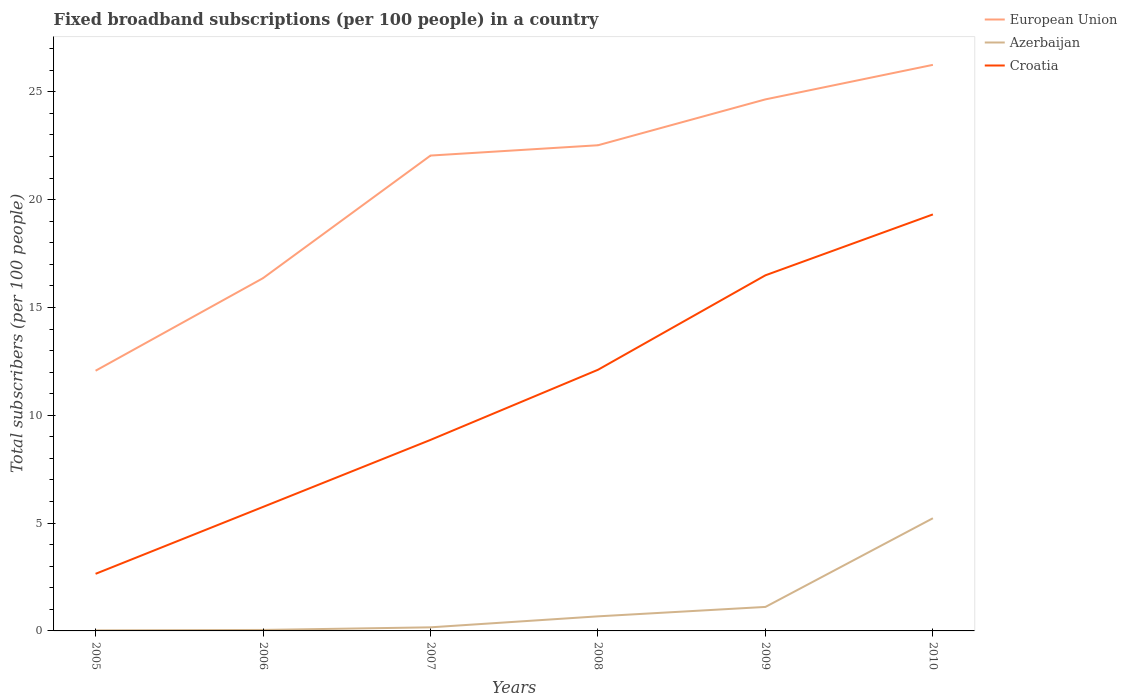How many different coloured lines are there?
Provide a short and direct response. 3. Does the line corresponding to European Union intersect with the line corresponding to Azerbaijan?
Give a very brief answer. No. Is the number of lines equal to the number of legend labels?
Make the answer very short. Yes. Across all years, what is the maximum number of broadband subscriptions in Croatia?
Provide a short and direct response. 2.65. What is the total number of broadband subscriptions in Croatia in the graph?
Offer a terse response. -3.11. What is the difference between the highest and the second highest number of broadband subscriptions in Croatia?
Offer a terse response. 16.67. What is the difference between the highest and the lowest number of broadband subscriptions in European Union?
Provide a succinct answer. 4. How many lines are there?
Your answer should be compact. 3. What is the difference between two consecutive major ticks on the Y-axis?
Make the answer very short. 5. How are the legend labels stacked?
Make the answer very short. Vertical. What is the title of the graph?
Provide a short and direct response. Fixed broadband subscriptions (per 100 people) in a country. Does "Egypt, Arab Rep." appear as one of the legend labels in the graph?
Offer a terse response. No. What is the label or title of the Y-axis?
Offer a terse response. Total subscribers (per 100 people). What is the Total subscribers (per 100 people) in European Union in 2005?
Your response must be concise. 12.07. What is the Total subscribers (per 100 people) of Azerbaijan in 2005?
Give a very brief answer. 0.03. What is the Total subscribers (per 100 people) of Croatia in 2005?
Your response must be concise. 2.65. What is the Total subscribers (per 100 people) of European Union in 2006?
Give a very brief answer. 16.36. What is the Total subscribers (per 100 people) in Azerbaijan in 2006?
Keep it short and to the point. 0.05. What is the Total subscribers (per 100 people) in Croatia in 2006?
Give a very brief answer. 5.75. What is the Total subscribers (per 100 people) in European Union in 2007?
Make the answer very short. 22.04. What is the Total subscribers (per 100 people) in Azerbaijan in 2007?
Ensure brevity in your answer.  0.17. What is the Total subscribers (per 100 people) in Croatia in 2007?
Offer a terse response. 8.86. What is the Total subscribers (per 100 people) in European Union in 2008?
Provide a short and direct response. 22.52. What is the Total subscribers (per 100 people) of Azerbaijan in 2008?
Your answer should be compact. 0.68. What is the Total subscribers (per 100 people) in Croatia in 2008?
Give a very brief answer. 12.11. What is the Total subscribers (per 100 people) of European Union in 2009?
Keep it short and to the point. 24.65. What is the Total subscribers (per 100 people) in Azerbaijan in 2009?
Give a very brief answer. 1.11. What is the Total subscribers (per 100 people) in Croatia in 2009?
Give a very brief answer. 16.49. What is the Total subscribers (per 100 people) in European Union in 2010?
Offer a very short reply. 26.25. What is the Total subscribers (per 100 people) in Azerbaijan in 2010?
Make the answer very short. 5.23. What is the Total subscribers (per 100 people) of Croatia in 2010?
Your answer should be very brief. 19.31. Across all years, what is the maximum Total subscribers (per 100 people) of European Union?
Offer a terse response. 26.25. Across all years, what is the maximum Total subscribers (per 100 people) in Azerbaijan?
Offer a terse response. 5.23. Across all years, what is the maximum Total subscribers (per 100 people) of Croatia?
Give a very brief answer. 19.31. Across all years, what is the minimum Total subscribers (per 100 people) of European Union?
Keep it short and to the point. 12.07. Across all years, what is the minimum Total subscribers (per 100 people) in Azerbaijan?
Give a very brief answer. 0.03. Across all years, what is the minimum Total subscribers (per 100 people) in Croatia?
Give a very brief answer. 2.65. What is the total Total subscribers (per 100 people) in European Union in the graph?
Provide a succinct answer. 123.89. What is the total Total subscribers (per 100 people) of Azerbaijan in the graph?
Ensure brevity in your answer.  7.25. What is the total Total subscribers (per 100 people) of Croatia in the graph?
Offer a very short reply. 65.17. What is the difference between the Total subscribers (per 100 people) in European Union in 2005 and that in 2006?
Your response must be concise. -4.29. What is the difference between the Total subscribers (per 100 people) in Azerbaijan in 2005 and that in 2006?
Offer a very short reply. -0.02. What is the difference between the Total subscribers (per 100 people) in Croatia in 2005 and that in 2006?
Make the answer very short. -3.1. What is the difference between the Total subscribers (per 100 people) of European Union in 2005 and that in 2007?
Make the answer very short. -9.98. What is the difference between the Total subscribers (per 100 people) in Azerbaijan in 2005 and that in 2007?
Keep it short and to the point. -0.14. What is the difference between the Total subscribers (per 100 people) of Croatia in 2005 and that in 2007?
Make the answer very short. -6.21. What is the difference between the Total subscribers (per 100 people) in European Union in 2005 and that in 2008?
Ensure brevity in your answer.  -10.46. What is the difference between the Total subscribers (per 100 people) in Azerbaijan in 2005 and that in 2008?
Offer a very short reply. -0.65. What is the difference between the Total subscribers (per 100 people) of Croatia in 2005 and that in 2008?
Provide a short and direct response. -9.46. What is the difference between the Total subscribers (per 100 people) in European Union in 2005 and that in 2009?
Provide a succinct answer. -12.58. What is the difference between the Total subscribers (per 100 people) of Azerbaijan in 2005 and that in 2009?
Ensure brevity in your answer.  -1.09. What is the difference between the Total subscribers (per 100 people) of Croatia in 2005 and that in 2009?
Your answer should be compact. -13.84. What is the difference between the Total subscribers (per 100 people) in European Union in 2005 and that in 2010?
Make the answer very short. -14.18. What is the difference between the Total subscribers (per 100 people) in Azerbaijan in 2005 and that in 2010?
Provide a short and direct response. -5.2. What is the difference between the Total subscribers (per 100 people) of Croatia in 2005 and that in 2010?
Your answer should be compact. -16.67. What is the difference between the Total subscribers (per 100 people) in European Union in 2006 and that in 2007?
Ensure brevity in your answer.  -5.68. What is the difference between the Total subscribers (per 100 people) in Azerbaijan in 2006 and that in 2007?
Keep it short and to the point. -0.12. What is the difference between the Total subscribers (per 100 people) of Croatia in 2006 and that in 2007?
Ensure brevity in your answer.  -3.11. What is the difference between the Total subscribers (per 100 people) of European Union in 2006 and that in 2008?
Make the answer very short. -6.16. What is the difference between the Total subscribers (per 100 people) in Azerbaijan in 2006 and that in 2008?
Keep it short and to the point. -0.63. What is the difference between the Total subscribers (per 100 people) in Croatia in 2006 and that in 2008?
Give a very brief answer. -6.36. What is the difference between the Total subscribers (per 100 people) of European Union in 2006 and that in 2009?
Make the answer very short. -8.29. What is the difference between the Total subscribers (per 100 people) of Azerbaijan in 2006 and that in 2009?
Provide a succinct answer. -1.07. What is the difference between the Total subscribers (per 100 people) in Croatia in 2006 and that in 2009?
Your answer should be compact. -10.74. What is the difference between the Total subscribers (per 100 people) in European Union in 2006 and that in 2010?
Your answer should be very brief. -9.89. What is the difference between the Total subscribers (per 100 people) in Azerbaijan in 2006 and that in 2010?
Offer a terse response. -5.18. What is the difference between the Total subscribers (per 100 people) of Croatia in 2006 and that in 2010?
Give a very brief answer. -13.56. What is the difference between the Total subscribers (per 100 people) of European Union in 2007 and that in 2008?
Keep it short and to the point. -0.48. What is the difference between the Total subscribers (per 100 people) of Azerbaijan in 2007 and that in 2008?
Provide a succinct answer. -0.51. What is the difference between the Total subscribers (per 100 people) in Croatia in 2007 and that in 2008?
Ensure brevity in your answer.  -3.25. What is the difference between the Total subscribers (per 100 people) of European Union in 2007 and that in 2009?
Keep it short and to the point. -2.61. What is the difference between the Total subscribers (per 100 people) of Azerbaijan in 2007 and that in 2009?
Provide a short and direct response. -0.95. What is the difference between the Total subscribers (per 100 people) of Croatia in 2007 and that in 2009?
Your answer should be compact. -7.63. What is the difference between the Total subscribers (per 100 people) of European Union in 2007 and that in 2010?
Your response must be concise. -4.21. What is the difference between the Total subscribers (per 100 people) in Azerbaijan in 2007 and that in 2010?
Provide a short and direct response. -5.06. What is the difference between the Total subscribers (per 100 people) in Croatia in 2007 and that in 2010?
Ensure brevity in your answer.  -10.46. What is the difference between the Total subscribers (per 100 people) of European Union in 2008 and that in 2009?
Your answer should be very brief. -2.13. What is the difference between the Total subscribers (per 100 people) in Azerbaijan in 2008 and that in 2009?
Your answer should be very brief. -0.44. What is the difference between the Total subscribers (per 100 people) in Croatia in 2008 and that in 2009?
Offer a very short reply. -4.38. What is the difference between the Total subscribers (per 100 people) of European Union in 2008 and that in 2010?
Give a very brief answer. -3.73. What is the difference between the Total subscribers (per 100 people) in Azerbaijan in 2008 and that in 2010?
Give a very brief answer. -4.55. What is the difference between the Total subscribers (per 100 people) in Croatia in 2008 and that in 2010?
Ensure brevity in your answer.  -7.2. What is the difference between the Total subscribers (per 100 people) in European Union in 2009 and that in 2010?
Ensure brevity in your answer.  -1.6. What is the difference between the Total subscribers (per 100 people) of Azerbaijan in 2009 and that in 2010?
Provide a short and direct response. -4.11. What is the difference between the Total subscribers (per 100 people) of Croatia in 2009 and that in 2010?
Make the answer very short. -2.82. What is the difference between the Total subscribers (per 100 people) of European Union in 2005 and the Total subscribers (per 100 people) of Azerbaijan in 2006?
Offer a terse response. 12.02. What is the difference between the Total subscribers (per 100 people) of European Union in 2005 and the Total subscribers (per 100 people) of Croatia in 2006?
Make the answer very short. 6.31. What is the difference between the Total subscribers (per 100 people) of Azerbaijan in 2005 and the Total subscribers (per 100 people) of Croatia in 2006?
Ensure brevity in your answer.  -5.73. What is the difference between the Total subscribers (per 100 people) in European Union in 2005 and the Total subscribers (per 100 people) in Azerbaijan in 2007?
Your answer should be very brief. 11.9. What is the difference between the Total subscribers (per 100 people) of European Union in 2005 and the Total subscribers (per 100 people) of Croatia in 2007?
Provide a succinct answer. 3.21. What is the difference between the Total subscribers (per 100 people) of Azerbaijan in 2005 and the Total subscribers (per 100 people) of Croatia in 2007?
Your answer should be very brief. -8.83. What is the difference between the Total subscribers (per 100 people) of European Union in 2005 and the Total subscribers (per 100 people) of Azerbaijan in 2008?
Your response must be concise. 11.39. What is the difference between the Total subscribers (per 100 people) of European Union in 2005 and the Total subscribers (per 100 people) of Croatia in 2008?
Your answer should be compact. -0.04. What is the difference between the Total subscribers (per 100 people) of Azerbaijan in 2005 and the Total subscribers (per 100 people) of Croatia in 2008?
Provide a short and direct response. -12.08. What is the difference between the Total subscribers (per 100 people) of European Union in 2005 and the Total subscribers (per 100 people) of Azerbaijan in 2009?
Your answer should be compact. 10.95. What is the difference between the Total subscribers (per 100 people) in European Union in 2005 and the Total subscribers (per 100 people) in Croatia in 2009?
Make the answer very short. -4.43. What is the difference between the Total subscribers (per 100 people) in Azerbaijan in 2005 and the Total subscribers (per 100 people) in Croatia in 2009?
Offer a terse response. -16.47. What is the difference between the Total subscribers (per 100 people) in European Union in 2005 and the Total subscribers (per 100 people) in Azerbaijan in 2010?
Keep it short and to the point. 6.84. What is the difference between the Total subscribers (per 100 people) in European Union in 2005 and the Total subscribers (per 100 people) in Croatia in 2010?
Keep it short and to the point. -7.25. What is the difference between the Total subscribers (per 100 people) in Azerbaijan in 2005 and the Total subscribers (per 100 people) in Croatia in 2010?
Your answer should be compact. -19.29. What is the difference between the Total subscribers (per 100 people) of European Union in 2006 and the Total subscribers (per 100 people) of Azerbaijan in 2007?
Make the answer very short. 16.19. What is the difference between the Total subscribers (per 100 people) of European Union in 2006 and the Total subscribers (per 100 people) of Croatia in 2007?
Provide a succinct answer. 7.5. What is the difference between the Total subscribers (per 100 people) of Azerbaijan in 2006 and the Total subscribers (per 100 people) of Croatia in 2007?
Provide a succinct answer. -8.81. What is the difference between the Total subscribers (per 100 people) in European Union in 2006 and the Total subscribers (per 100 people) in Azerbaijan in 2008?
Provide a short and direct response. 15.68. What is the difference between the Total subscribers (per 100 people) of European Union in 2006 and the Total subscribers (per 100 people) of Croatia in 2008?
Your answer should be compact. 4.25. What is the difference between the Total subscribers (per 100 people) of Azerbaijan in 2006 and the Total subscribers (per 100 people) of Croatia in 2008?
Provide a short and direct response. -12.06. What is the difference between the Total subscribers (per 100 people) of European Union in 2006 and the Total subscribers (per 100 people) of Azerbaijan in 2009?
Provide a succinct answer. 15.25. What is the difference between the Total subscribers (per 100 people) in European Union in 2006 and the Total subscribers (per 100 people) in Croatia in 2009?
Your response must be concise. -0.13. What is the difference between the Total subscribers (per 100 people) of Azerbaijan in 2006 and the Total subscribers (per 100 people) of Croatia in 2009?
Your response must be concise. -16.45. What is the difference between the Total subscribers (per 100 people) in European Union in 2006 and the Total subscribers (per 100 people) in Azerbaijan in 2010?
Keep it short and to the point. 11.13. What is the difference between the Total subscribers (per 100 people) in European Union in 2006 and the Total subscribers (per 100 people) in Croatia in 2010?
Make the answer very short. -2.96. What is the difference between the Total subscribers (per 100 people) in Azerbaijan in 2006 and the Total subscribers (per 100 people) in Croatia in 2010?
Offer a terse response. -19.27. What is the difference between the Total subscribers (per 100 people) in European Union in 2007 and the Total subscribers (per 100 people) in Azerbaijan in 2008?
Provide a succinct answer. 21.37. What is the difference between the Total subscribers (per 100 people) in European Union in 2007 and the Total subscribers (per 100 people) in Croatia in 2008?
Your answer should be very brief. 9.93. What is the difference between the Total subscribers (per 100 people) of Azerbaijan in 2007 and the Total subscribers (per 100 people) of Croatia in 2008?
Your answer should be compact. -11.94. What is the difference between the Total subscribers (per 100 people) of European Union in 2007 and the Total subscribers (per 100 people) of Azerbaijan in 2009?
Offer a terse response. 20.93. What is the difference between the Total subscribers (per 100 people) in European Union in 2007 and the Total subscribers (per 100 people) in Croatia in 2009?
Keep it short and to the point. 5.55. What is the difference between the Total subscribers (per 100 people) in Azerbaijan in 2007 and the Total subscribers (per 100 people) in Croatia in 2009?
Your answer should be compact. -16.32. What is the difference between the Total subscribers (per 100 people) in European Union in 2007 and the Total subscribers (per 100 people) in Azerbaijan in 2010?
Make the answer very short. 16.82. What is the difference between the Total subscribers (per 100 people) in European Union in 2007 and the Total subscribers (per 100 people) in Croatia in 2010?
Your answer should be very brief. 2.73. What is the difference between the Total subscribers (per 100 people) in Azerbaijan in 2007 and the Total subscribers (per 100 people) in Croatia in 2010?
Your answer should be very brief. -19.15. What is the difference between the Total subscribers (per 100 people) of European Union in 2008 and the Total subscribers (per 100 people) of Azerbaijan in 2009?
Keep it short and to the point. 21.41. What is the difference between the Total subscribers (per 100 people) of European Union in 2008 and the Total subscribers (per 100 people) of Croatia in 2009?
Keep it short and to the point. 6.03. What is the difference between the Total subscribers (per 100 people) of Azerbaijan in 2008 and the Total subscribers (per 100 people) of Croatia in 2009?
Your response must be concise. -15.82. What is the difference between the Total subscribers (per 100 people) in European Union in 2008 and the Total subscribers (per 100 people) in Azerbaijan in 2010?
Make the answer very short. 17.3. What is the difference between the Total subscribers (per 100 people) of European Union in 2008 and the Total subscribers (per 100 people) of Croatia in 2010?
Your answer should be very brief. 3.21. What is the difference between the Total subscribers (per 100 people) in Azerbaijan in 2008 and the Total subscribers (per 100 people) in Croatia in 2010?
Offer a very short reply. -18.64. What is the difference between the Total subscribers (per 100 people) in European Union in 2009 and the Total subscribers (per 100 people) in Azerbaijan in 2010?
Provide a succinct answer. 19.42. What is the difference between the Total subscribers (per 100 people) in European Union in 2009 and the Total subscribers (per 100 people) in Croatia in 2010?
Your response must be concise. 5.33. What is the difference between the Total subscribers (per 100 people) of Azerbaijan in 2009 and the Total subscribers (per 100 people) of Croatia in 2010?
Your answer should be compact. -18.2. What is the average Total subscribers (per 100 people) in European Union per year?
Your answer should be very brief. 20.65. What is the average Total subscribers (per 100 people) in Azerbaijan per year?
Provide a short and direct response. 1.21. What is the average Total subscribers (per 100 people) in Croatia per year?
Offer a terse response. 10.86. In the year 2005, what is the difference between the Total subscribers (per 100 people) of European Union and Total subscribers (per 100 people) of Azerbaijan?
Provide a succinct answer. 12.04. In the year 2005, what is the difference between the Total subscribers (per 100 people) of European Union and Total subscribers (per 100 people) of Croatia?
Offer a terse response. 9.42. In the year 2005, what is the difference between the Total subscribers (per 100 people) of Azerbaijan and Total subscribers (per 100 people) of Croatia?
Your response must be concise. -2.62. In the year 2006, what is the difference between the Total subscribers (per 100 people) of European Union and Total subscribers (per 100 people) of Azerbaijan?
Provide a short and direct response. 16.31. In the year 2006, what is the difference between the Total subscribers (per 100 people) in European Union and Total subscribers (per 100 people) in Croatia?
Provide a succinct answer. 10.61. In the year 2006, what is the difference between the Total subscribers (per 100 people) in Azerbaijan and Total subscribers (per 100 people) in Croatia?
Provide a succinct answer. -5.71. In the year 2007, what is the difference between the Total subscribers (per 100 people) of European Union and Total subscribers (per 100 people) of Azerbaijan?
Ensure brevity in your answer.  21.88. In the year 2007, what is the difference between the Total subscribers (per 100 people) in European Union and Total subscribers (per 100 people) in Croatia?
Ensure brevity in your answer.  13.19. In the year 2007, what is the difference between the Total subscribers (per 100 people) in Azerbaijan and Total subscribers (per 100 people) in Croatia?
Provide a succinct answer. -8.69. In the year 2008, what is the difference between the Total subscribers (per 100 people) of European Union and Total subscribers (per 100 people) of Azerbaijan?
Provide a short and direct response. 21.85. In the year 2008, what is the difference between the Total subscribers (per 100 people) of European Union and Total subscribers (per 100 people) of Croatia?
Ensure brevity in your answer.  10.41. In the year 2008, what is the difference between the Total subscribers (per 100 people) of Azerbaijan and Total subscribers (per 100 people) of Croatia?
Offer a very short reply. -11.43. In the year 2009, what is the difference between the Total subscribers (per 100 people) of European Union and Total subscribers (per 100 people) of Azerbaijan?
Give a very brief answer. 23.54. In the year 2009, what is the difference between the Total subscribers (per 100 people) of European Union and Total subscribers (per 100 people) of Croatia?
Offer a very short reply. 8.16. In the year 2009, what is the difference between the Total subscribers (per 100 people) in Azerbaijan and Total subscribers (per 100 people) in Croatia?
Provide a short and direct response. -15.38. In the year 2010, what is the difference between the Total subscribers (per 100 people) in European Union and Total subscribers (per 100 people) in Azerbaijan?
Offer a terse response. 21.02. In the year 2010, what is the difference between the Total subscribers (per 100 people) in European Union and Total subscribers (per 100 people) in Croatia?
Your answer should be very brief. 6.94. In the year 2010, what is the difference between the Total subscribers (per 100 people) in Azerbaijan and Total subscribers (per 100 people) in Croatia?
Offer a terse response. -14.09. What is the ratio of the Total subscribers (per 100 people) in European Union in 2005 to that in 2006?
Offer a very short reply. 0.74. What is the ratio of the Total subscribers (per 100 people) of Azerbaijan in 2005 to that in 2006?
Your answer should be compact. 0.56. What is the ratio of the Total subscribers (per 100 people) in Croatia in 2005 to that in 2006?
Offer a terse response. 0.46. What is the ratio of the Total subscribers (per 100 people) of European Union in 2005 to that in 2007?
Provide a succinct answer. 0.55. What is the ratio of the Total subscribers (per 100 people) of Azerbaijan in 2005 to that in 2007?
Provide a succinct answer. 0.15. What is the ratio of the Total subscribers (per 100 people) of Croatia in 2005 to that in 2007?
Ensure brevity in your answer.  0.3. What is the ratio of the Total subscribers (per 100 people) of European Union in 2005 to that in 2008?
Your response must be concise. 0.54. What is the ratio of the Total subscribers (per 100 people) of Azerbaijan in 2005 to that in 2008?
Provide a succinct answer. 0.04. What is the ratio of the Total subscribers (per 100 people) in Croatia in 2005 to that in 2008?
Your answer should be very brief. 0.22. What is the ratio of the Total subscribers (per 100 people) of European Union in 2005 to that in 2009?
Offer a very short reply. 0.49. What is the ratio of the Total subscribers (per 100 people) of Azerbaijan in 2005 to that in 2009?
Make the answer very short. 0.02. What is the ratio of the Total subscribers (per 100 people) of Croatia in 2005 to that in 2009?
Offer a very short reply. 0.16. What is the ratio of the Total subscribers (per 100 people) in European Union in 2005 to that in 2010?
Provide a short and direct response. 0.46. What is the ratio of the Total subscribers (per 100 people) of Azerbaijan in 2005 to that in 2010?
Offer a terse response. 0. What is the ratio of the Total subscribers (per 100 people) in Croatia in 2005 to that in 2010?
Make the answer very short. 0.14. What is the ratio of the Total subscribers (per 100 people) in European Union in 2006 to that in 2007?
Your answer should be very brief. 0.74. What is the ratio of the Total subscribers (per 100 people) of Azerbaijan in 2006 to that in 2007?
Give a very brief answer. 0.27. What is the ratio of the Total subscribers (per 100 people) of Croatia in 2006 to that in 2007?
Keep it short and to the point. 0.65. What is the ratio of the Total subscribers (per 100 people) of European Union in 2006 to that in 2008?
Keep it short and to the point. 0.73. What is the ratio of the Total subscribers (per 100 people) in Azerbaijan in 2006 to that in 2008?
Provide a short and direct response. 0.07. What is the ratio of the Total subscribers (per 100 people) of Croatia in 2006 to that in 2008?
Offer a very short reply. 0.47. What is the ratio of the Total subscribers (per 100 people) of European Union in 2006 to that in 2009?
Your response must be concise. 0.66. What is the ratio of the Total subscribers (per 100 people) of Azerbaijan in 2006 to that in 2009?
Provide a short and direct response. 0.04. What is the ratio of the Total subscribers (per 100 people) of Croatia in 2006 to that in 2009?
Your answer should be compact. 0.35. What is the ratio of the Total subscribers (per 100 people) of European Union in 2006 to that in 2010?
Your response must be concise. 0.62. What is the ratio of the Total subscribers (per 100 people) of Azerbaijan in 2006 to that in 2010?
Your answer should be very brief. 0.01. What is the ratio of the Total subscribers (per 100 people) in Croatia in 2006 to that in 2010?
Your answer should be compact. 0.3. What is the ratio of the Total subscribers (per 100 people) in European Union in 2007 to that in 2008?
Provide a short and direct response. 0.98. What is the ratio of the Total subscribers (per 100 people) in Azerbaijan in 2007 to that in 2008?
Provide a succinct answer. 0.25. What is the ratio of the Total subscribers (per 100 people) of Croatia in 2007 to that in 2008?
Keep it short and to the point. 0.73. What is the ratio of the Total subscribers (per 100 people) in European Union in 2007 to that in 2009?
Your response must be concise. 0.89. What is the ratio of the Total subscribers (per 100 people) in Azerbaijan in 2007 to that in 2009?
Provide a short and direct response. 0.15. What is the ratio of the Total subscribers (per 100 people) in Croatia in 2007 to that in 2009?
Your response must be concise. 0.54. What is the ratio of the Total subscribers (per 100 people) of European Union in 2007 to that in 2010?
Your response must be concise. 0.84. What is the ratio of the Total subscribers (per 100 people) in Azerbaijan in 2007 to that in 2010?
Give a very brief answer. 0.03. What is the ratio of the Total subscribers (per 100 people) of Croatia in 2007 to that in 2010?
Offer a very short reply. 0.46. What is the ratio of the Total subscribers (per 100 people) of European Union in 2008 to that in 2009?
Your response must be concise. 0.91. What is the ratio of the Total subscribers (per 100 people) of Azerbaijan in 2008 to that in 2009?
Provide a short and direct response. 0.61. What is the ratio of the Total subscribers (per 100 people) in Croatia in 2008 to that in 2009?
Give a very brief answer. 0.73. What is the ratio of the Total subscribers (per 100 people) of European Union in 2008 to that in 2010?
Give a very brief answer. 0.86. What is the ratio of the Total subscribers (per 100 people) in Azerbaijan in 2008 to that in 2010?
Your response must be concise. 0.13. What is the ratio of the Total subscribers (per 100 people) in Croatia in 2008 to that in 2010?
Provide a short and direct response. 0.63. What is the ratio of the Total subscribers (per 100 people) in European Union in 2009 to that in 2010?
Provide a short and direct response. 0.94. What is the ratio of the Total subscribers (per 100 people) in Azerbaijan in 2009 to that in 2010?
Keep it short and to the point. 0.21. What is the ratio of the Total subscribers (per 100 people) of Croatia in 2009 to that in 2010?
Provide a short and direct response. 0.85. What is the difference between the highest and the second highest Total subscribers (per 100 people) in European Union?
Keep it short and to the point. 1.6. What is the difference between the highest and the second highest Total subscribers (per 100 people) of Azerbaijan?
Ensure brevity in your answer.  4.11. What is the difference between the highest and the second highest Total subscribers (per 100 people) of Croatia?
Your answer should be very brief. 2.82. What is the difference between the highest and the lowest Total subscribers (per 100 people) in European Union?
Your answer should be compact. 14.18. What is the difference between the highest and the lowest Total subscribers (per 100 people) in Azerbaijan?
Ensure brevity in your answer.  5.2. What is the difference between the highest and the lowest Total subscribers (per 100 people) of Croatia?
Offer a terse response. 16.67. 